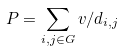<formula> <loc_0><loc_0><loc_500><loc_500>P = \sum _ { i , j \in G } v / d _ { i , j }</formula> 